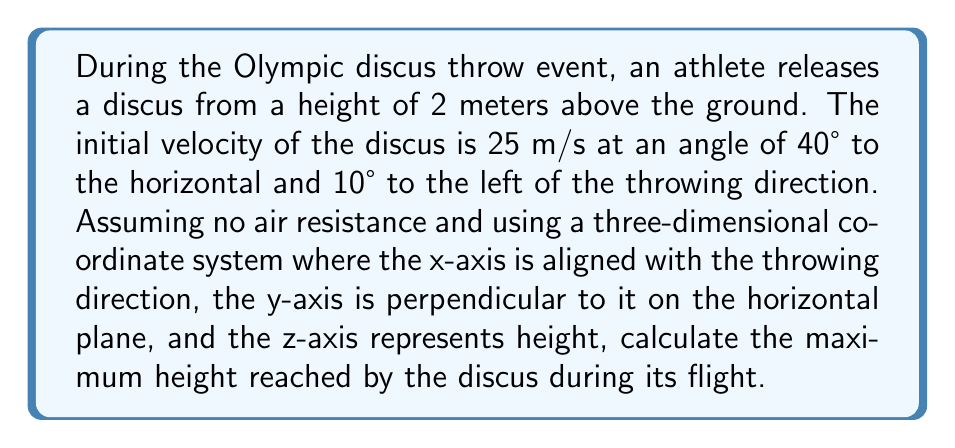Teach me how to tackle this problem. To solve this problem, we'll follow these steps:

1) First, let's break down the initial velocity into its components:

   $v_x = v \cos(40°) \cos(10°) = 25 \cdot 0.7660 \cdot 0.9848 = 18.88$ m/s
   $v_y = v \cos(40°) \sin(10°) = 25 \cdot 0.7660 \cdot 0.1736 = 3.33$ m/s
   $v_z = v \sin(40°) = 25 \cdot 0.6428 = 16.07$ m/s

2) The maximum height is determined by the vertical motion (z-axis). We can use the equation:

   $$h_{max} = h_0 + \frac{v_z^2}{2g}$$

   Where $h_0$ is the initial height, $v_z$ is the initial vertical velocity, and $g$ is the acceleration due to gravity (9.8 m/s²).

3) Plugging in our values:

   $$h_{max} = 2 + \frac{16.07^2}{2 \cdot 9.8}$$

4) Simplifying:

   $$h_{max} = 2 + \frac{258.2449}{19.6} = 2 + 13.18 = 15.18$$ meters

Therefore, the discus reaches a maximum height of 15.18 meters above the ground.
Answer: 15.18 m 